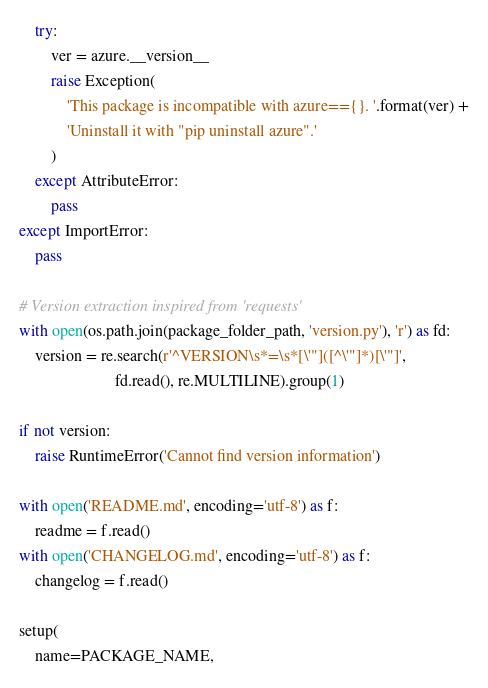Convert code to text. <code><loc_0><loc_0><loc_500><loc_500><_Python_>    try:
        ver = azure.__version__
        raise Exception(
            'This package is incompatible with azure=={}. '.format(ver) +
            'Uninstall it with "pip uninstall azure".'
        )
    except AttributeError:
        pass
except ImportError:
    pass

# Version extraction inspired from 'requests'
with open(os.path.join(package_folder_path, 'version.py'), 'r') as fd:
    version = re.search(r'^VERSION\s*=\s*[\'"]([^\'"]*)[\'"]',
                        fd.read(), re.MULTILINE).group(1)

if not version:
    raise RuntimeError('Cannot find version information')

with open('README.md', encoding='utf-8') as f:
    readme = f.read()
with open('CHANGELOG.md', encoding='utf-8') as f:
    changelog = f.read()

setup(
    name=PACKAGE_NAME,</code> 